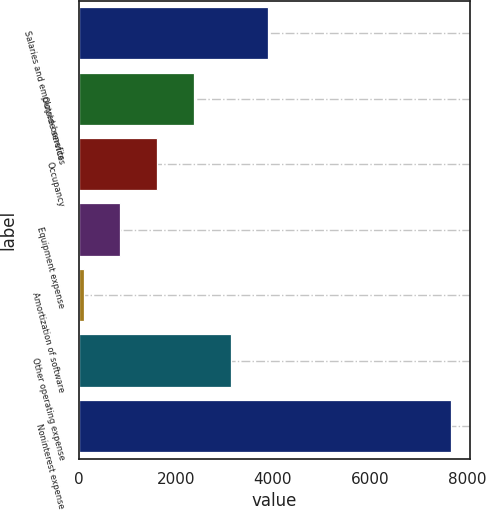Convert chart to OTSL. <chart><loc_0><loc_0><loc_500><loc_500><bar_chart><fcel>Salaries and employee benefits<fcel>Outside services<fcel>Occupancy<fcel>Equipment expense<fcel>Amortization of software<fcel>Other operating expense<fcel>Noninterest expense<nl><fcel>3890.5<fcel>2375.1<fcel>1617.4<fcel>859.7<fcel>102<fcel>3132.8<fcel>7679<nl></chart> 